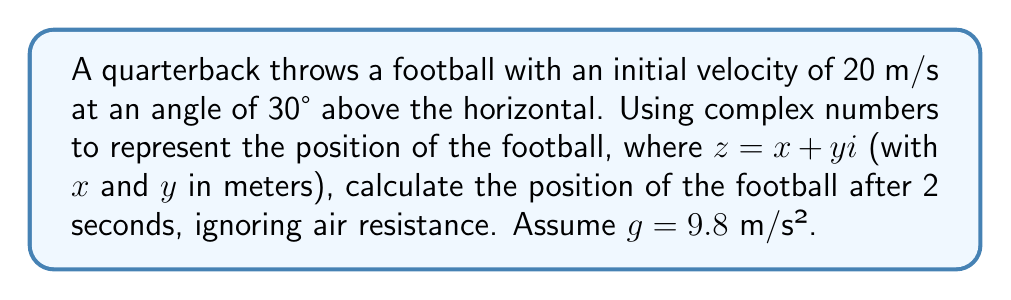Can you answer this question? Let's approach this step-by-step using complex numbers:

1) First, we need to break down the initial velocity into its horizontal and vertical components:
   $v_x = 20 \cos(30°) = 20 \cdot \frac{\sqrt{3}}{2} = 10\sqrt{3}$ m/s
   $v_y = 20 \sin(30°) = 20 \cdot \frac{1}{2} = 10$ m/s

2) Now, we can use the equations of motion for constant acceleration:
   $x = v_x t$
   $y = v_y t - \frac{1}{2}gt^2$

3) Substituting $t = 2$ seconds:
   $x = 10\sqrt{3} \cdot 2 = 20\sqrt{3}$ m
   $y = 10 \cdot 2 - \frac{1}{2} \cdot 9.8 \cdot 2^2 = 20 - 19.6 = 0.4$ m

4) We can represent this position as a complex number:
   $z = x + yi = 20\sqrt{3} + 0.4i$ m

5) To simplify, we can approximate $\sqrt{3} \approx 1.732$:
   $z \approx 34.64 + 0.4i$ m

This complex number represents the position of the football after 2 seconds, where the real part is the horizontal distance and the imaginary part is the vertical height.
Answer: $z \approx 34.64 + 0.4i$ m 